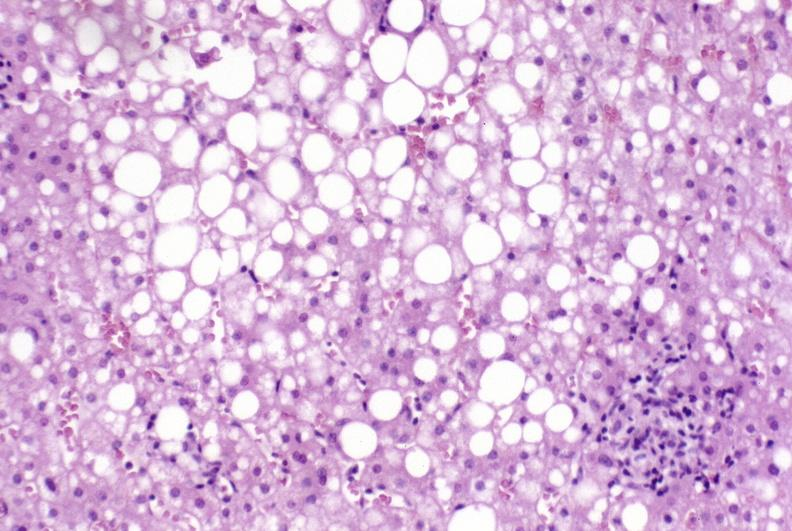s liver present?
Answer the question using a single word or phrase. Yes 